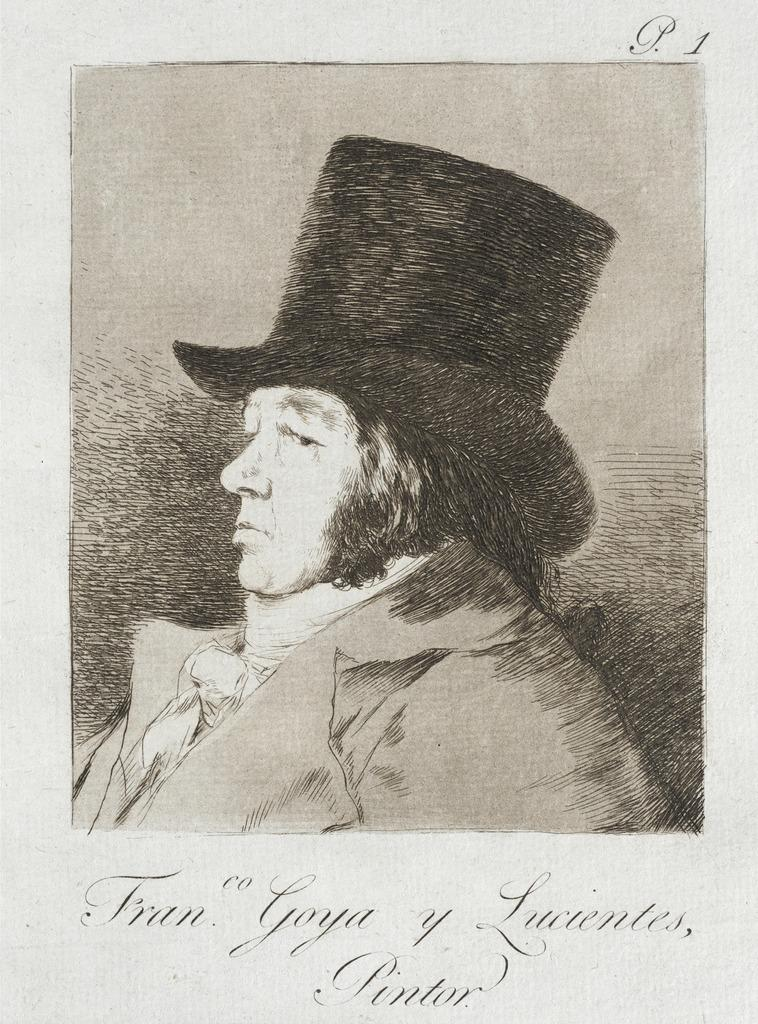What is depicted on the paper in the image? There is a picture of a person printed on a paper in the image. What else can be seen on the paper besides the picture of the person? There is text present below the picture of the person. What type of mitten is the person wearing in the image? There is no person wearing a mitten in the image, as it only shows a picture of a person printed on a paper. 